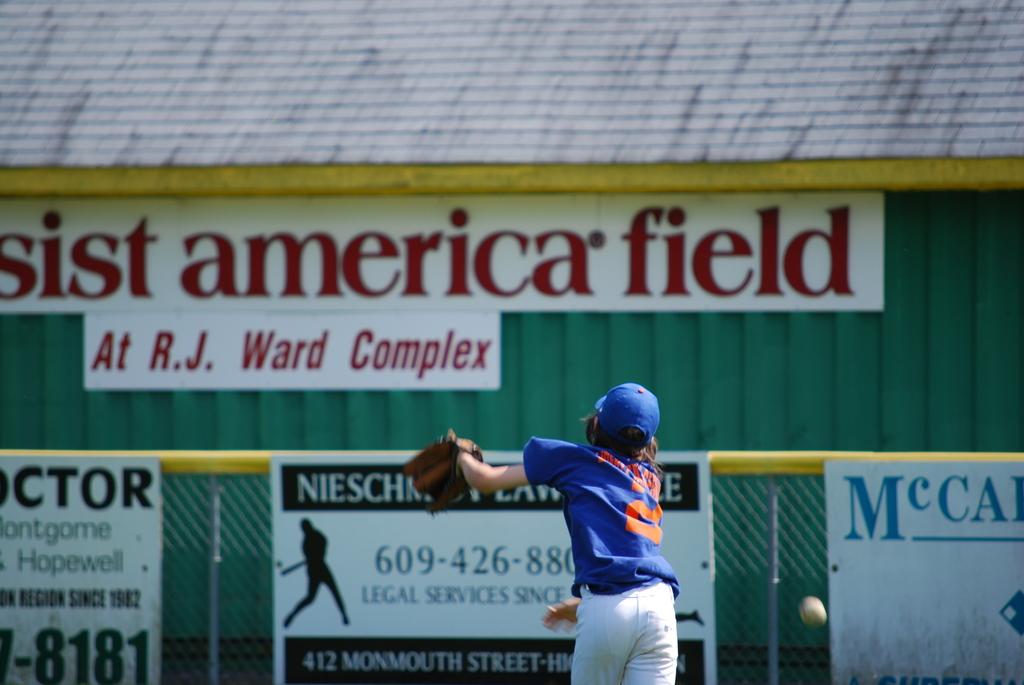What are the last four numbers of the phone number on the left?
Ensure brevity in your answer.  8181. 